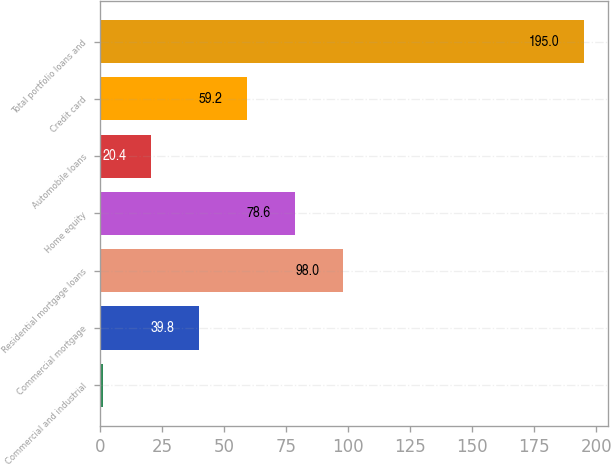Convert chart. <chart><loc_0><loc_0><loc_500><loc_500><bar_chart><fcel>Commercial and industrial<fcel>Commercial mortgage<fcel>Residential mortgage loans<fcel>Home equity<fcel>Automobile loans<fcel>Credit card<fcel>Total portfolio loans and<nl><fcel>1<fcel>39.8<fcel>98<fcel>78.6<fcel>20.4<fcel>59.2<fcel>195<nl></chart> 